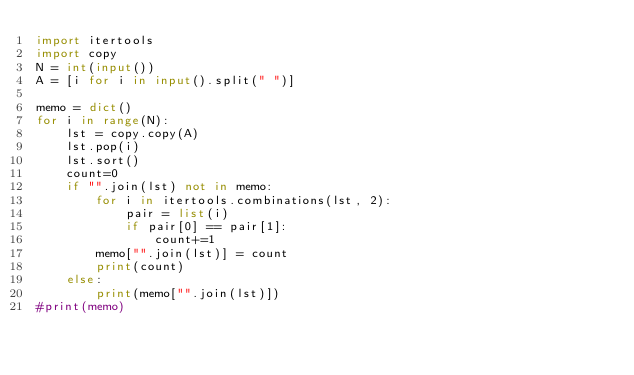Convert code to text. <code><loc_0><loc_0><loc_500><loc_500><_Python_>import itertools
import copy
N = int(input())
A = [i for i in input().split(" ")]

memo = dict()
for i in range(N):
    lst = copy.copy(A)
    lst.pop(i)
    lst.sort()
    count=0
    if "".join(lst) not in memo:
        for i in itertools.combinations(lst, 2):
            pair = list(i)
            if pair[0] == pair[1]:
                count+=1
        memo["".join(lst)] = count
        print(count)
    else:
        print(memo["".join(lst)])
#print(memo)
</code> 